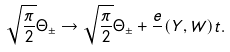Convert formula to latex. <formula><loc_0><loc_0><loc_500><loc_500>\sqrt { \frac { \pi } { 2 } } \Theta _ { \pm } \rightarrow \sqrt { \frac { \pi } { 2 } } \Theta _ { \pm } + \frac { e } { } ( Y , W ) t .</formula> 